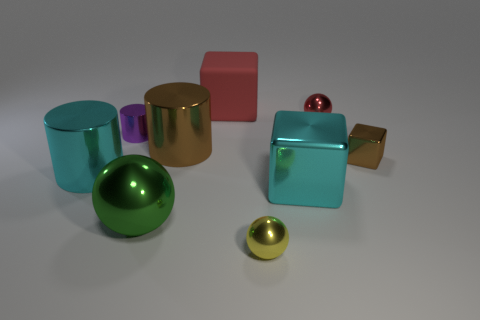Add 1 red objects. How many objects exist? 10 Subtract all cylinders. How many objects are left? 6 Add 8 green spheres. How many green spheres are left? 9 Add 6 gray things. How many gray things exist? 6 Subtract 0 cyan balls. How many objects are left? 9 Subtract all small red spheres. Subtract all purple shiny cylinders. How many objects are left? 7 